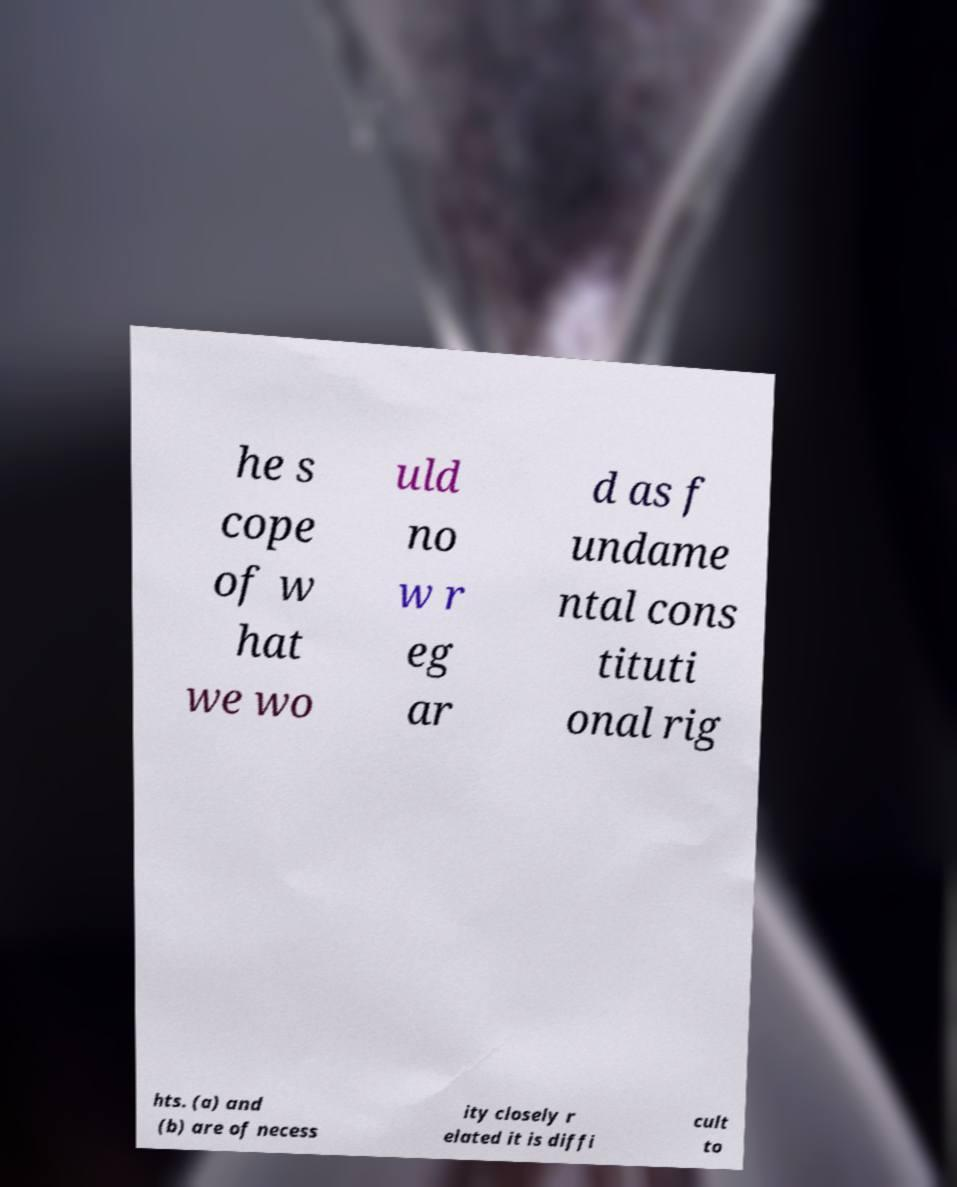Could you extract and type out the text from this image? he s cope of w hat we wo uld no w r eg ar d as f undame ntal cons tituti onal rig hts. (a) and (b) are of necess ity closely r elated it is diffi cult to 